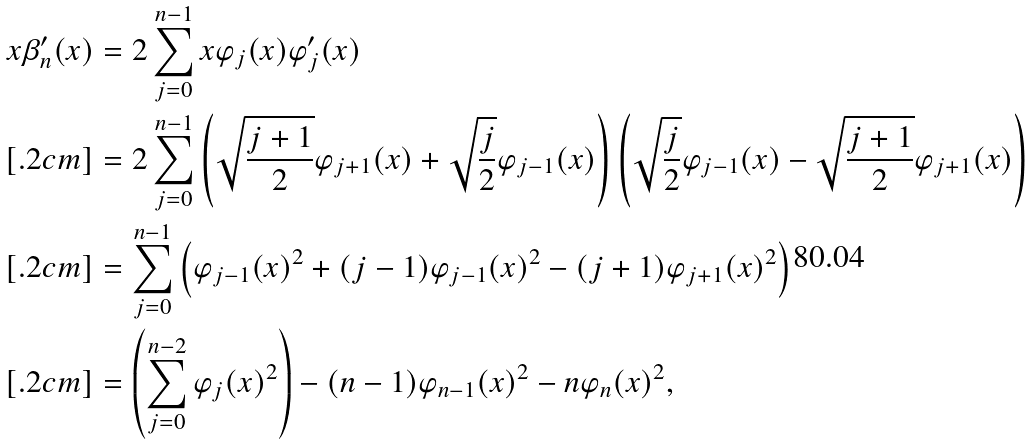Convert formula to latex. <formula><loc_0><loc_0><loc_500><loc_500>x \beta _ { n } ^ { \prime } ( x ) & = 2 \sum _ { j = 0 } ^ { n - 1 } x \varphi _ { j } ( x ) \varphi _ { j } ^ { \prime } ( x ) \\ [ . 2 c m ] & = 2 \sum _ { j = 0 } ^ { n - 1 } \left ( \sqrt { \frac { j + 1 } { 2 } } \varphi _ { j + 1 } ( x ) + \sqrt { \frac { j } { 2 } } \varphi _ { j - 1 } ( x ) \right ) \left ( \sqrt { \frac { j } { 2 } } \varphi _ { j - 1 } ( x ) - \sqrt { \frac { j + 1 } { 2 } } \varphi _ { j + 1 } ( x ) \right ) \\ [ . 2 c m ] & = \sum _ { j = 0 } ^ { n - 1 } \left ( \varphi _ { j - 1 } ( x ) ^ { 2 } + ( j - 1 ) \varphi _ { j - 1 } ( x ) ^ { 2 } - ( j + 1 ) \varphi _ { j + 1 } ( x ) ^ { 2 } \right ) \\ [ . 2 c m ] & = \left ( \sum _ { j = 0 } ^ { n - 2 } \varphi _ { j } ( x ) ^ { 2 } \right ) - ( n - 1 ) \varphi _ { n - 1 } ( x ) ^ { 2 } - n \varphi _ { n } ( x ) ^ { 2 } ,</formula> 